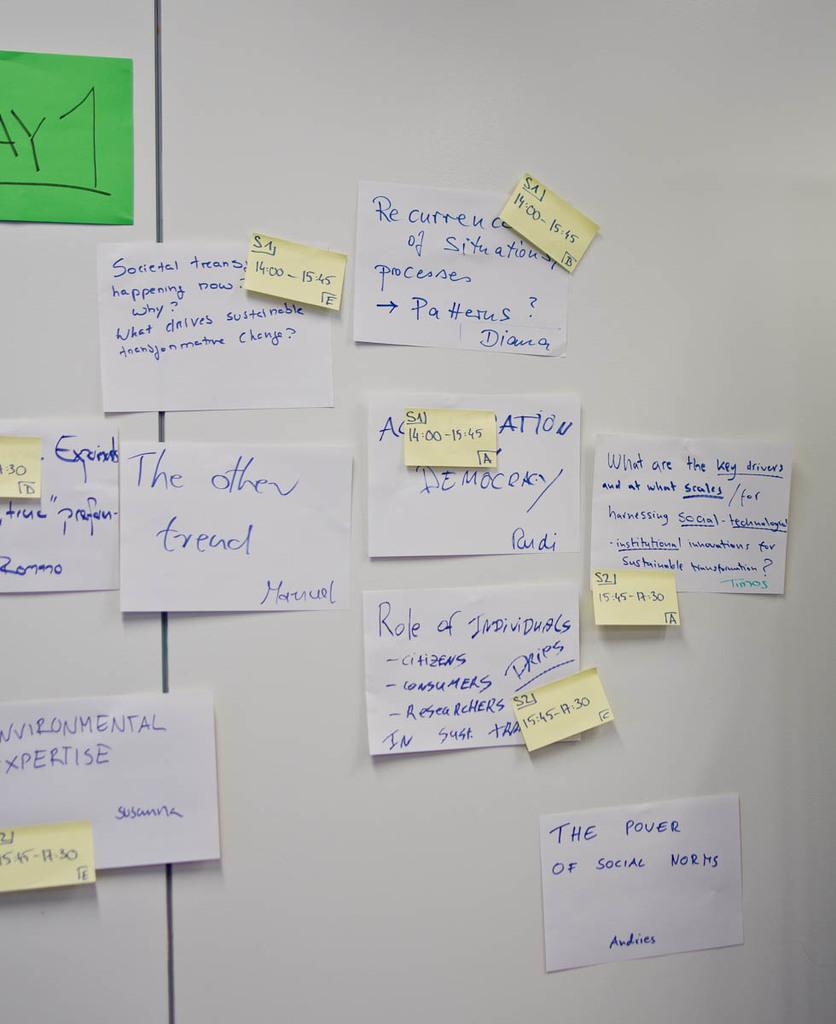What are the last three words at the bottom of the page?
Offer a very short reply. Of social norms. 